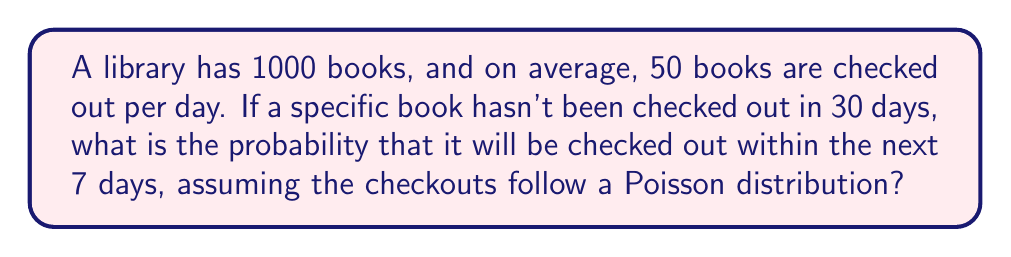Help me with this question. Let's approach this step-by-step:

1) First, we need to calculate the rate parameter $\lambda$ for the Poisson distribution. This is the average number of times a specific book is checked out in 7 days.

   $\lambda = \frac{\text{books checked out per day} \times \text{number of days}}{\text{total number of books}}$

   $\lambda = \frac{50 \times 7}{1000} = 0.35$

2) The probability of the book not being checked out in 7 days is given by the Poisson probability of 0 occurrences:

   $P(X = 0) = \frac{e^{-\lambda} \lambda^0}{0!} = e^{-\lambda}$

   $P(X = 0) = e^{-0.35} \approx 0.7047$

3) Therefore, the probability of the book being checked out at least once in 7 days is:

   $P(X \geq 1) = 1 - P(X = 0) = 1 - e^{-0.35}$

4) Calculating this:

   $P(X \geq 1) = 1 - 0.7047 \approx 0.2953$

Thus, the probability of the book being checked out within the next 7 days is approximately 0.2953 or 29.53%.
Answer: $1 - e^{-0.35} \approx 0.2953$ 